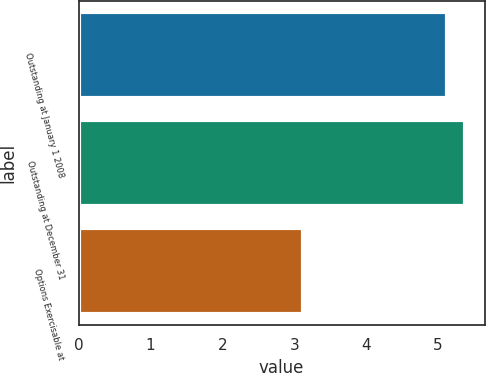Convert chart. <chart><loc_0><loc_0><loc_500><loc_500><bar_chart><fcel>Outstanding at January 1 2008<fcel>Outstanding at December 31<fcel>Options Exercisable at<nl><fcel>5.12<fcel>5.38<fcel>3.12<nl></chart> 